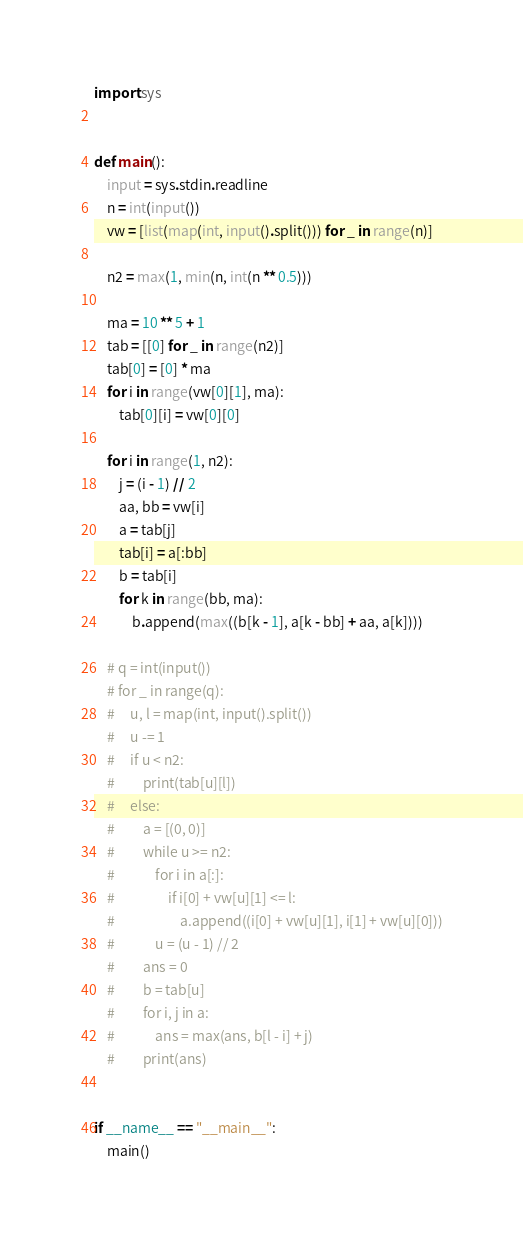<code> <loc_0><loc_0><loc_500><loc_500><_Python_>import sys


def main():
    input = sys.stdin.readline
    n = int(input())
    vw = [list(map(int, input().split())) for _ in range(n)]

    n2 = max(1, min(n, int(n ** 0.5)))

    ma = 10 ** 5 + 1
    tab = [[0] for _ in range(n2)]
    tab[0] = [0] * ma
    for i in range(vw[0][1], ma):
        tab[0][i] = vw[0][0]

    for i in range(1, n2):
        j = (i - 1) // 2
        aa, bb = vw[i]
        a = tab[j]
        tab[i] = a[:bb]
        b = tab[i]
        for k in range(bb, ma):
            b.append(max((b[k - 1], a[k - bb] + aa, a[k])))

    # q = int(input())
    # for _ in range(q):
    #     u, l = map(int, input().split())
    #     u -= 1
    #     if u < n2:
    #         print(tab[u][l])
    #     else:
    #         a = [(0, 0)]
    #         while u >= n2:
    #             for i in a[:]:
    #                 if i[0] + vw[u][1] <= l:
    #                     a.append((i[0] + vw[u][1], i[1] + vw[u][0]))
    #             u = (u - 1) // 2
    #         ans = 0
    #         b = tab[u]
    #         for i, j in a:
    #             ans = max(ans, b[l - i] + j)
    #         print(ans)


if __name__ == "__main__":
    main()
</code> 